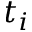<formula> <loc_0><loc_0><loc_500><loc_500>t _ { i }</formula> 